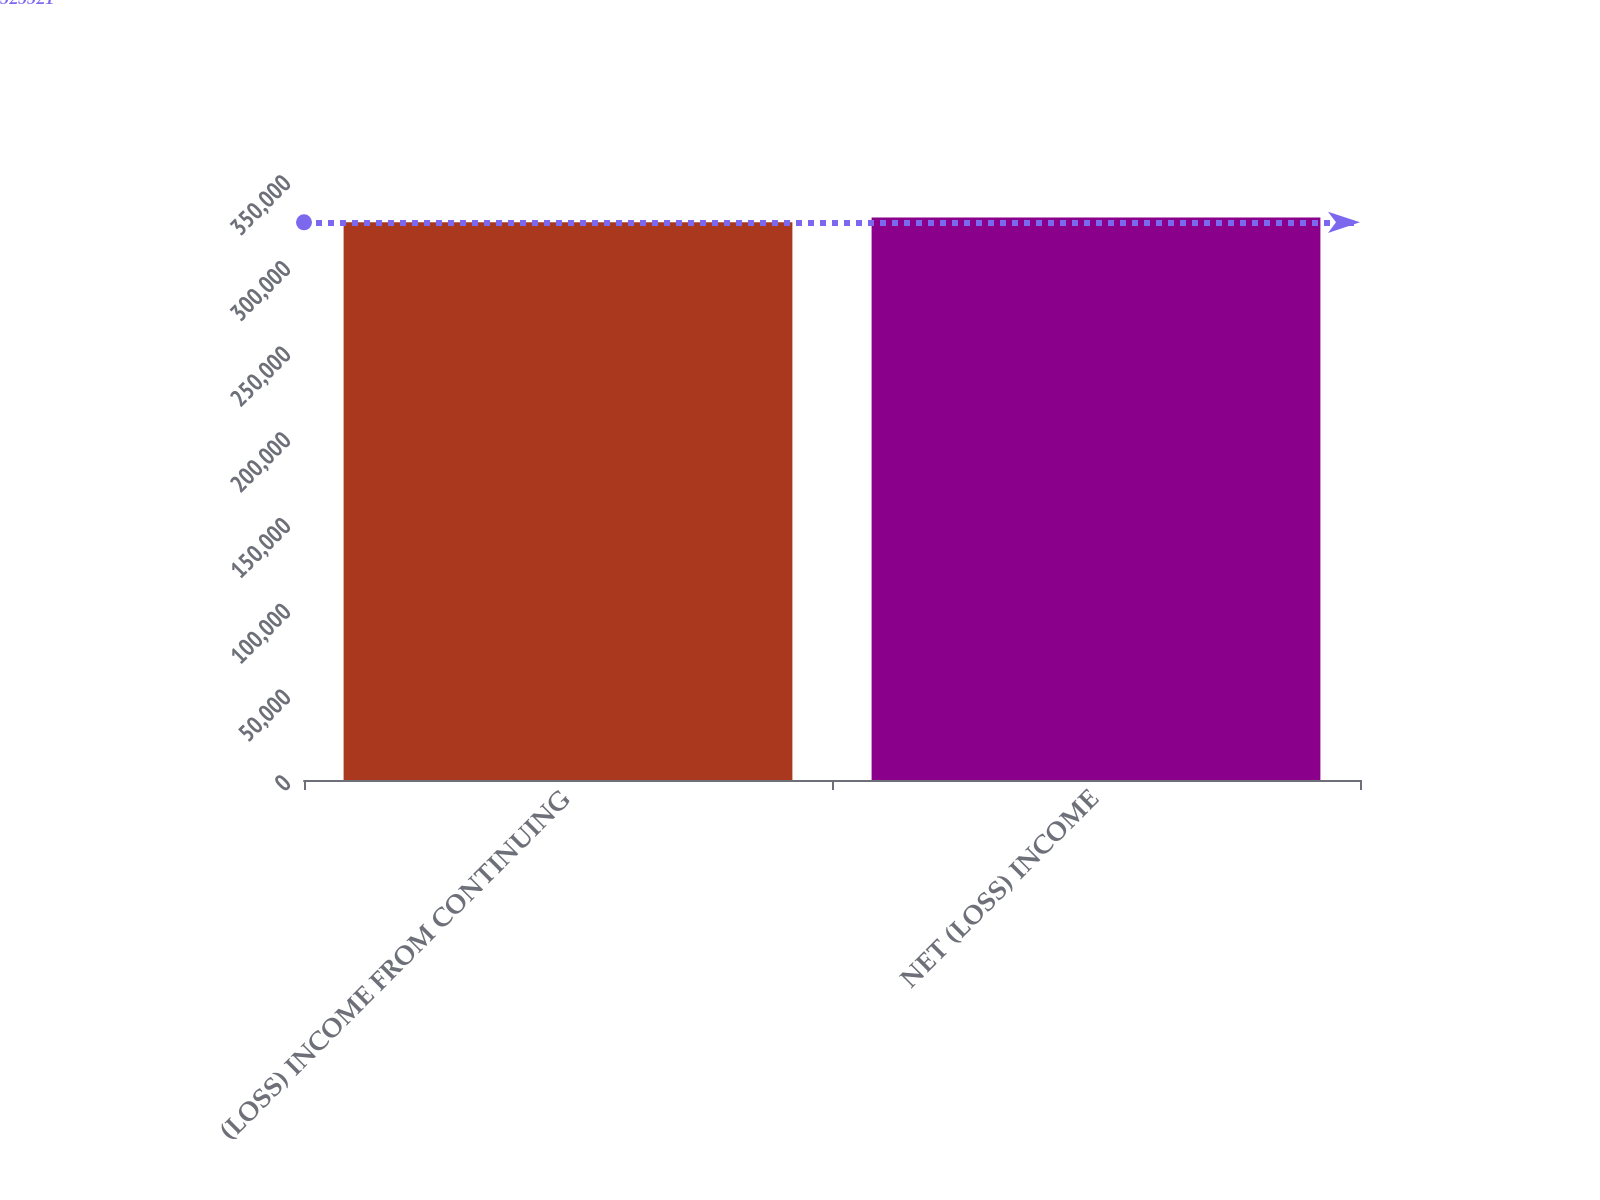Convert chart. <chart><loc_0><loc_0><loc_500><loc_500><bar_chart><fcel>(LOSS) INCOME FROM CONTINUING<fcel>NET (LOSS) INCOME<nl><fcel>325321<fcel>328081<nl></chart> 